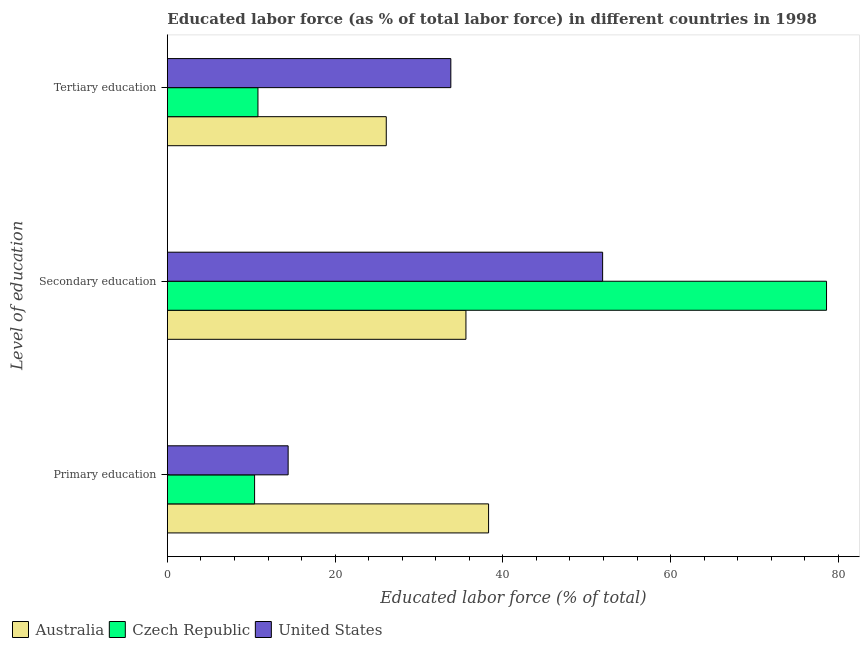How many different coloured bars are there?
Give a very brief answer. 3. How many groups of bars are there?
Keep it short and to the point. 3. Are the number of bars per tick equal to the number of legend labels?
Your answer should be compact. Yes. Are the number of bars on each tick of the Y-axis equal?
Give a very brief answer. Yes. How many bars are there on the 1st tick from the top?
Your response must be concise. 3. How many bars are there on the 2nd tick from the bottom?
Provide a succinct answer. 3. What is the label of the 3rd group of bars from the top?
Your response must be concise. Primary education. What is the percentage of labor force who received primary education in United States?
Provide a succinct answer. 14.4. Across all countries, what is the maximum percentage of labor force who received primary education?
Offer a terse response. 38.3. Across all countries, what is the minimum percentage of labor force who received primary education?
Offer a terse response. 10.4. In which country was the percentage of labor force who received secondary education minimum?
Offer a terse response. Australia. What is the total percentage of labor force who received primary education in the graph?
Offer a very short reply. 63.1. What is the difference between the percentage of labor force who received secondary education in Australia and that in United States?
Your response must be concise. -16.3. What is the difference between the percentage of labor force who received tertiary education in United States and the percentage of labor force who received secondary education in Czech Republic?
Offer a terse response. -44.8. What is the average percentage of labor force who received tertiary education per country?
Your answer should be compact. 23.57. What is the difference between the percentage of labor force who received primary education and percentage of labor force who received secondary education in United States?
Provide a succinct answer. -37.5. In how many countries, is the percentage of labor force who received primary education greater than 40 %?
Offer a terse response. 0. What is the ratio of the percentage of labor force who received primary education in Czech Republic to that in Australia?
Provide a short and direct response. 0.27. What is the difference between the highest and the second highest percentage of labor force who received primary education?
Provide a short and direct response. 23.9. What is the difference between the highest and the lowest percentage of labor force who received primary education?
Give a very brief answer. 27.9. Is the sum of the percentage of labor force who received tertiary education in Australia and Czech Republic greater than the maximum percentage of labor force who received primary education across all countries?
Keep it short and to the point. No. What does the 2nd bar from the top in Secondary education represents?
Provide a succinct answer. Czech Republic. What does the 2nd bar from the bottom in Primary education represents?
Give a very brief answer. Czech Republic. How many bars are there?
Your answer should be compact. 9. How many countries are there in the graph?
Provide a short and direct response. 3. What is the difference between two consecutive major ticks on the X-axis?
Keep it short and to the point. 20. Where does the legend appear in the graph?
Offer a terse response. Bottom left. How many legend labels are there?
Ensure brevity in your answer.  3. How are the legend labels stacked?
Your answer should be compact. Horizontal. What is the title of the graph?
Your answer should be compact. Educated labor force (as % of total labor force) in different countries in 1998. What is the label or title of the X-axis?
Make the answer very short. Educated labor force (% of total). What is the label or title of the Y-axis?
Provide a succinct answer. Level of education. What is the Educated labor force (% of total) of Australia in Primary education?
Make the answer very short. 38.3. What is the Educated labor force (% of total) in Czech Republic in Primary education?
Your answer should be very brief. 10.4. What is the Educated labor force (% of total) in United States in Primary education?
Keep it short and to the point. 14.4. What is the Educated labor force (% of total) of Australia in Secondary education?
Give a very brief answer. 35.6. What is the Educated labor force (% of total) of Czech Republic in Secondary education?
Give a very brief answer. 78.6. What is the Educated labor force (% of total) in United States in Secondary education?
Your answer should be very brief. 51.9. What is the Educated labor force (% of total) in Australia in Tertiary education?
Your answer should be very brief. 26.1. What is the Educated labor force (% of total) in Czech Republic in Tertiary education?
Offer a terse response. 10.8. What is the Educated labor force (% of total) in United States in Tertiary education?
Offer a very short reply. 33.8. Across all Level of education, what is the maximum Educated labor force (% of total) of Australia?
Ensure brevity in your answer.  38.3. Across all Level of education, what is the maximum Educated labor force (% of total) of Czech Republic?
Provide a short and direct response. 78.6. Across all Level of education, what is the maximum Educated labor force (% of total) of United States?
Keep it short and to the point. 51.9. Across all Level of education, what is the minimum Educated labor force (% of total) of Australia?
Provide a short and direct response. 26.1. Across all Level of education, what is the minimum Educated labor force (% of total) of Czech Republic?
Offer a very short reply. 10.4. Across all Level of education, what is the minimum Educated labor force (% of total) of United States?
Give a very brief answer. 14.4. What is the total Educated labor force (% of total) in Czech Republic in the graph?
Offer a terse response. 99.8. What is the total Educated labor force (% of total) in United States in the graph?
Make the answer very short. 100.1. What is the difference between the Educated labor force (% of total) in Australia in Primary education and that in Secondary education?
Provide a succinct answer. 2.7. What is the difference between the Educated labor force (% of total) in Czech Republic in Primary education and that in Secondary education?
Your response must be concise. -68.2. What is the difference between the Educated labor force (% of total) in United States in Primary education and that in Secondary education?
Your answer should be compact. -37.5. What is the difference between the Educated labor force (% of total) in Australia in Primary education and that in Tertiary education?
Provide a short and direct response. 12.2. What is the difference between the Educated labor force (% of total) of United States in Primary education and that in Tertiary education?
Provide a succinct answer. -19.4. What is the difference between the Educated labor force (% of total) of Australia in Secondary education and that in Tertiary education?
Make the answer very short. 9.5. What is the difference between the Educated labor force (% of total) in Czech Republic in Secondary education and that in Tertiary education?
Provide a short and direct response. 67.8. What is the difference between the Educated labor force (% of total) in Australia in Primary education and the Educated labor force (% of total) in Czech Republic in Secondary education?
Ensure brevity in your answer.  -40.3. What is the difference between the Educated labor force (% of total) of Czech Republic in Primary education and the Educated labor force (% of total) of United States in Secondary education?
Provide a succinct answer. -41.5. What is the difference between the Educated labor force (% of total) of Australia in Primary education and the Educated labor force (% of total) of Czech Republic in Tertiary education?
Keep it short and to the point. 27.5. What is the difference between the Educated labor force (% of total) in Czech Republic in Primary education and the Educated labor force (% of total) in United States in Tertiary education?
Give a very brief answer. -23.4. What is the difference between the Educated labor force (% of total) of Australia in Secondary education and the Educated labor force (% of total) of Czech Republic in Tertiary education?
Ensure brevity in your answer.  24.8. What is the difference between the Educated labor force (% of total) of Australia in Secondary education and the Educated labor force (% of total) of United States in Tertiary education?
Provide a short and direct response. 1.8. What is the difference between the Educated labor force (% of total) of Czech Republic in Secondary education and the Educated labor force (% of total) of United States in Tertiary education?
Offer a terse response. 44.8. What is the average Educated labor force (% of total) of Australia per Level of education?
Keep it short and to the point. 33.33. What is the average Educated labor force (% of total) in Czech Republic per Level of education?
Your answer should be compact. 33.27. What is the average Educated labor force (% of total) in United States per Level of education?
Provide a succinct answer. 33.37. What is the difference between the Educated labor force (% of total) in Australia and Educated labor force (% of total) in Czech Republic in Primary education?
Your answer should be compact. 27.9. What is the difference between the Educated labor force (% of total) of Australia and Educated labor force (% of total) of United States in Primary education?
Keep it short and to the point. 23.9. What is the difference between the Educated labor force (% of total) of Australia and Educated labor force (% of total) of Czech Republic in Secondary education?
Offer a very short reply. -43. What is the difference between the Educated labor force (% of total) of Australia and Educated labor force (% of total) of United States in Secondary education?
Provide a short and direct response. -16.3. What is the difference between the Educated labor force (% of total) of Czech Republic and Educated labor force (% of total) of United States in Secondary education?
Ensure brevity in your answer.  26.7. What is the difference between the Educated labor force (% of total) in Australia and Educated labor force (% of total) in Czech Republic in Tertiary education?
Make the answer very short. 15.3. What is the difference between the Educated labor force (% of total) of Czech Republic and Educated labor force (% of total) of United States in Tertiary education?
Ensure brevity in your answer.  -23. What is the ratio of the Educated labor force (% of total) of Australia in Primary education to that in Secondary education?
Provide a succinct answer. 1.08. What is the ratio of the Educated labor force (% of total) in Czech Republic in Primary education to that in Secondary education?
Keep it short and to the point. 0.13. What is the ratio of the Educated labor force (% of total) of United States in Primary education to that in Secondary education?
Give a very brief answer. 0.28. What is the ratio of the Educated labor force (% of total) in Australia in Primary education to that in Tertiary education?
Make the answer very short. 1.47. What is the ratio of the Educated labor force (% of total) of United States in Primary education to that in Tertiary education?
Keep it short and to the point. 0.43. What is the ratio of the Educated labor force (% of total) of Australia in Secondary education to that in Tertiary education?
Your response must be concise. 1.36. What is the ratio of the Educated labor force (% of total) of Czech Republic in Secondary education to that in Tertiary education?
Your response must be concise. 7.28. What is the ratio of the Educated labor force (% of total) in United States in Secondary education to that in Tertiary education?
Your answer should be very brief. 1.54. What is the difference between the highest and the second highest Educated labor force (% of total) in Czech Republic?
Ensure brevity in your answer.  67.8. What is the difference between the highest and the second highest Educated labor force (% of total) of United States?
Offer a terse response. 18.1. What is the difference between the highest and the lowest Educated labor force (% of total) in Czech Republic?
Give a very brief answer. 68.2. What is the difference between the highest and the lowest Educated labor force (% of total) in United States?
Provide a short and direct response. 37.5. 